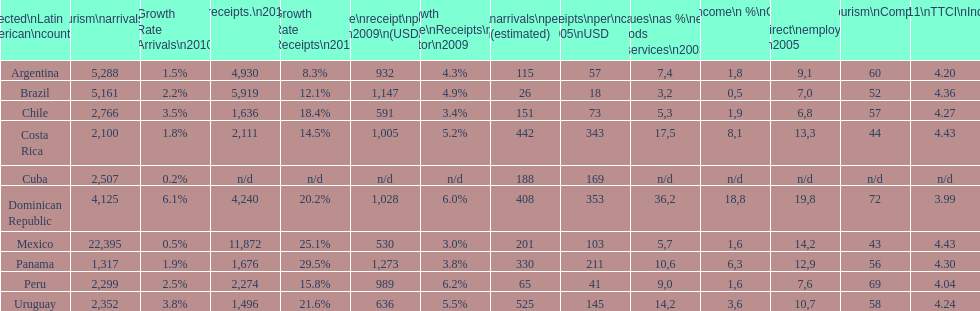Which nation recorded the greatest number of international visitors in the year 2010? Mexico. 